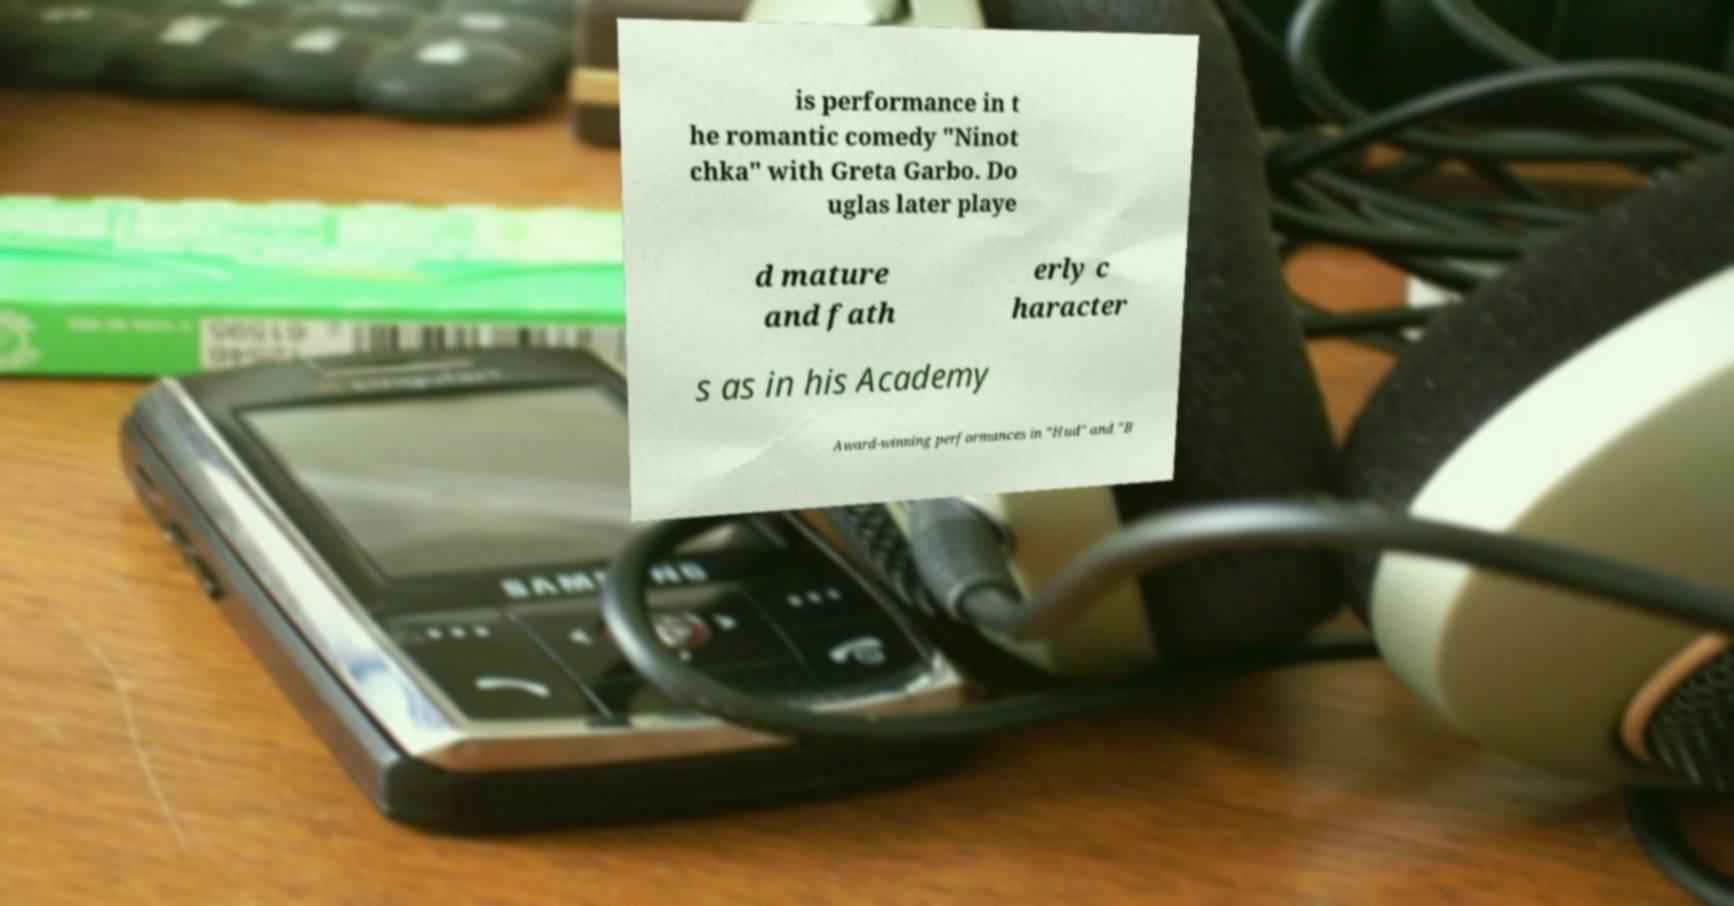For documentation purposes, I need the text within this image transcribed. Could you provide that? is performance in t he romantic comedy "Ninot chka" with Greta Garbo. Do uglas later playe d mature and fath erly c haracter s as in his Academy Award-winning performances in "Hud" and "B 